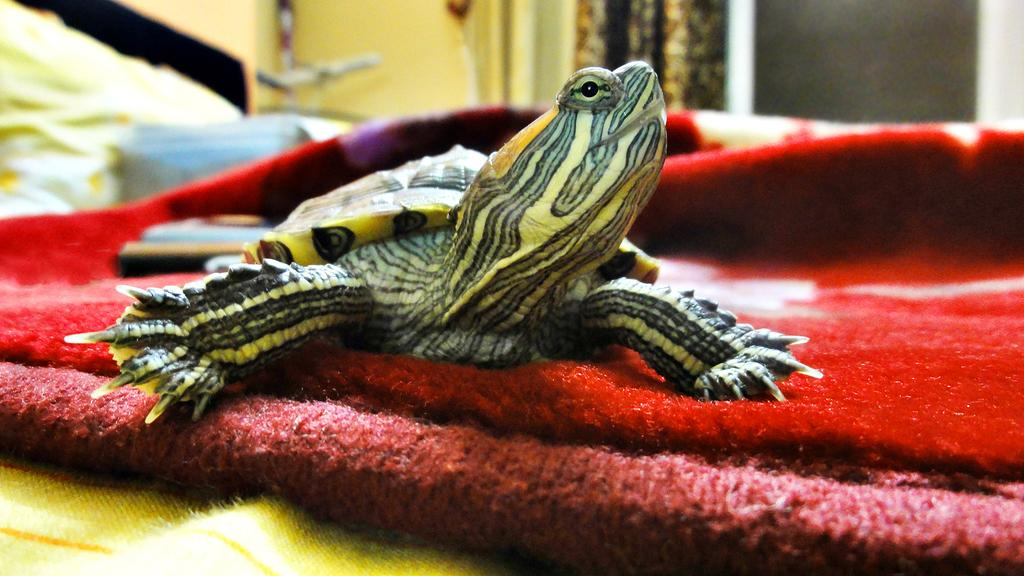What animal is the main subject of the image? There is a tortoise in the image. What is the tortoise resting on? The tortoise is on a cloth. Can you describe the background of the image? The background of the image is blurred. What type of weather can be seen in the image? There is no weather visible in the image, as it is focused on the tortoise and the cloth. What type of trousers is the tortoise wearing in the image? Tortoises do not wear trousers, and there is no indication of any clothing in the image. 